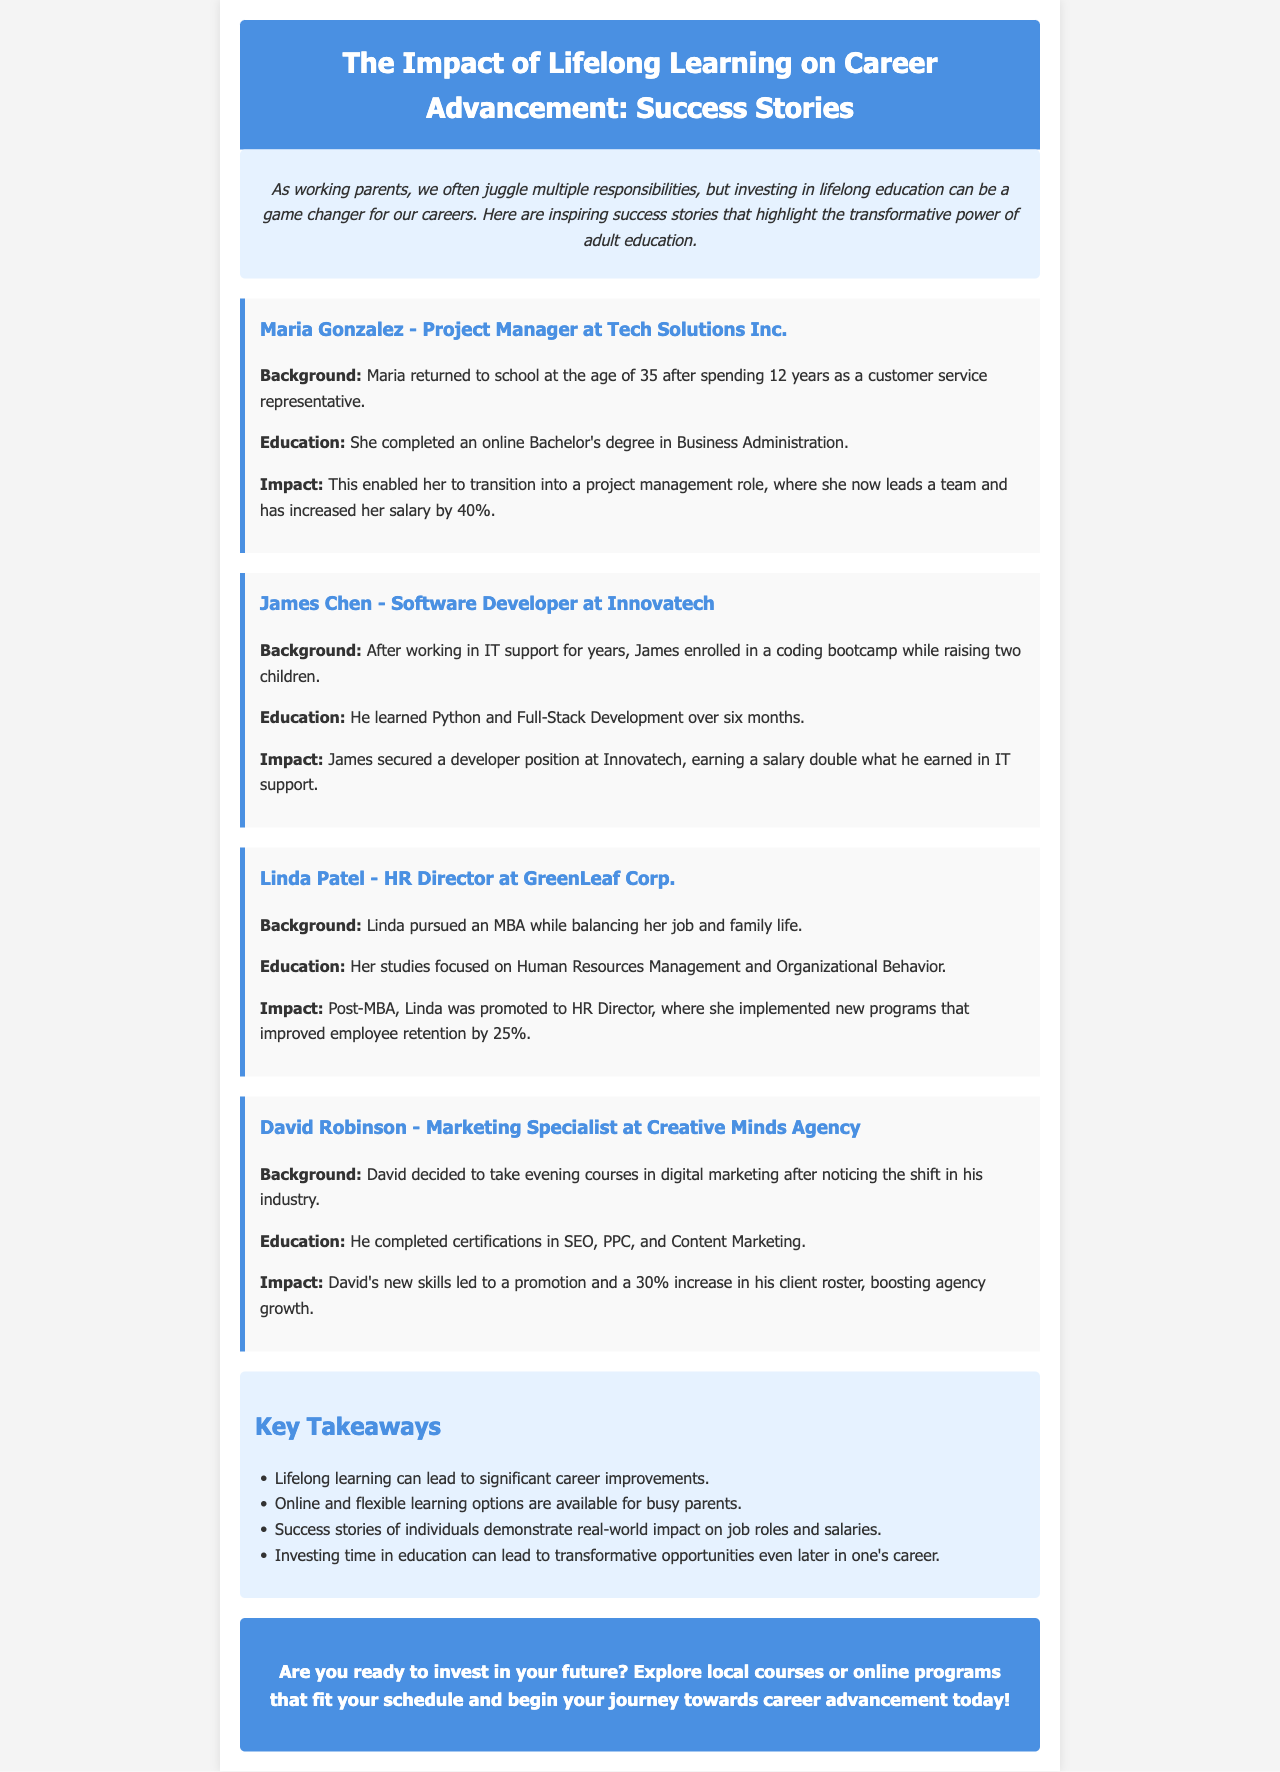What degree did Maria Gonzalez complete? Maria completed an online Bachelor's degree in Business Administration.
Answer: Bachelor's degree in Business Administration How much did James Chen's salary increase? James secured a developer position earning a salary double what he earned in IT support.
Answer: Double What was Linda Patel's focus in her MBA studies? Linda's studies focused on Human Resources Management and Organizational Behavior.
Answer: Human Resources Management and Organizational Behavior What percentage did employee retention improve under Linda Patel's leadership? Linda implemented new programs that improved employee retention by 25%.
Answer: 25% What subjects did David Robinson complete certifications in? David completed certifications in SEO, PPC, and Content Marketing.
Answer: SEO, PPC, and Content Marketing What is a key takeaway about lifelong learning mentioned in the document? One of the takeaways states that lifelong learning can lead to significant career improvements.
Answer: Significant career improvements How did Maria Gonzalez's career change after education? Maria transitioned into a project management role after completing her education.
Answer: Project management role What type of learning options are mentioned as available for busy parents? The document mentions that online and flexible learning options are available for busy parents.
Answer: Online and flexible learning options 